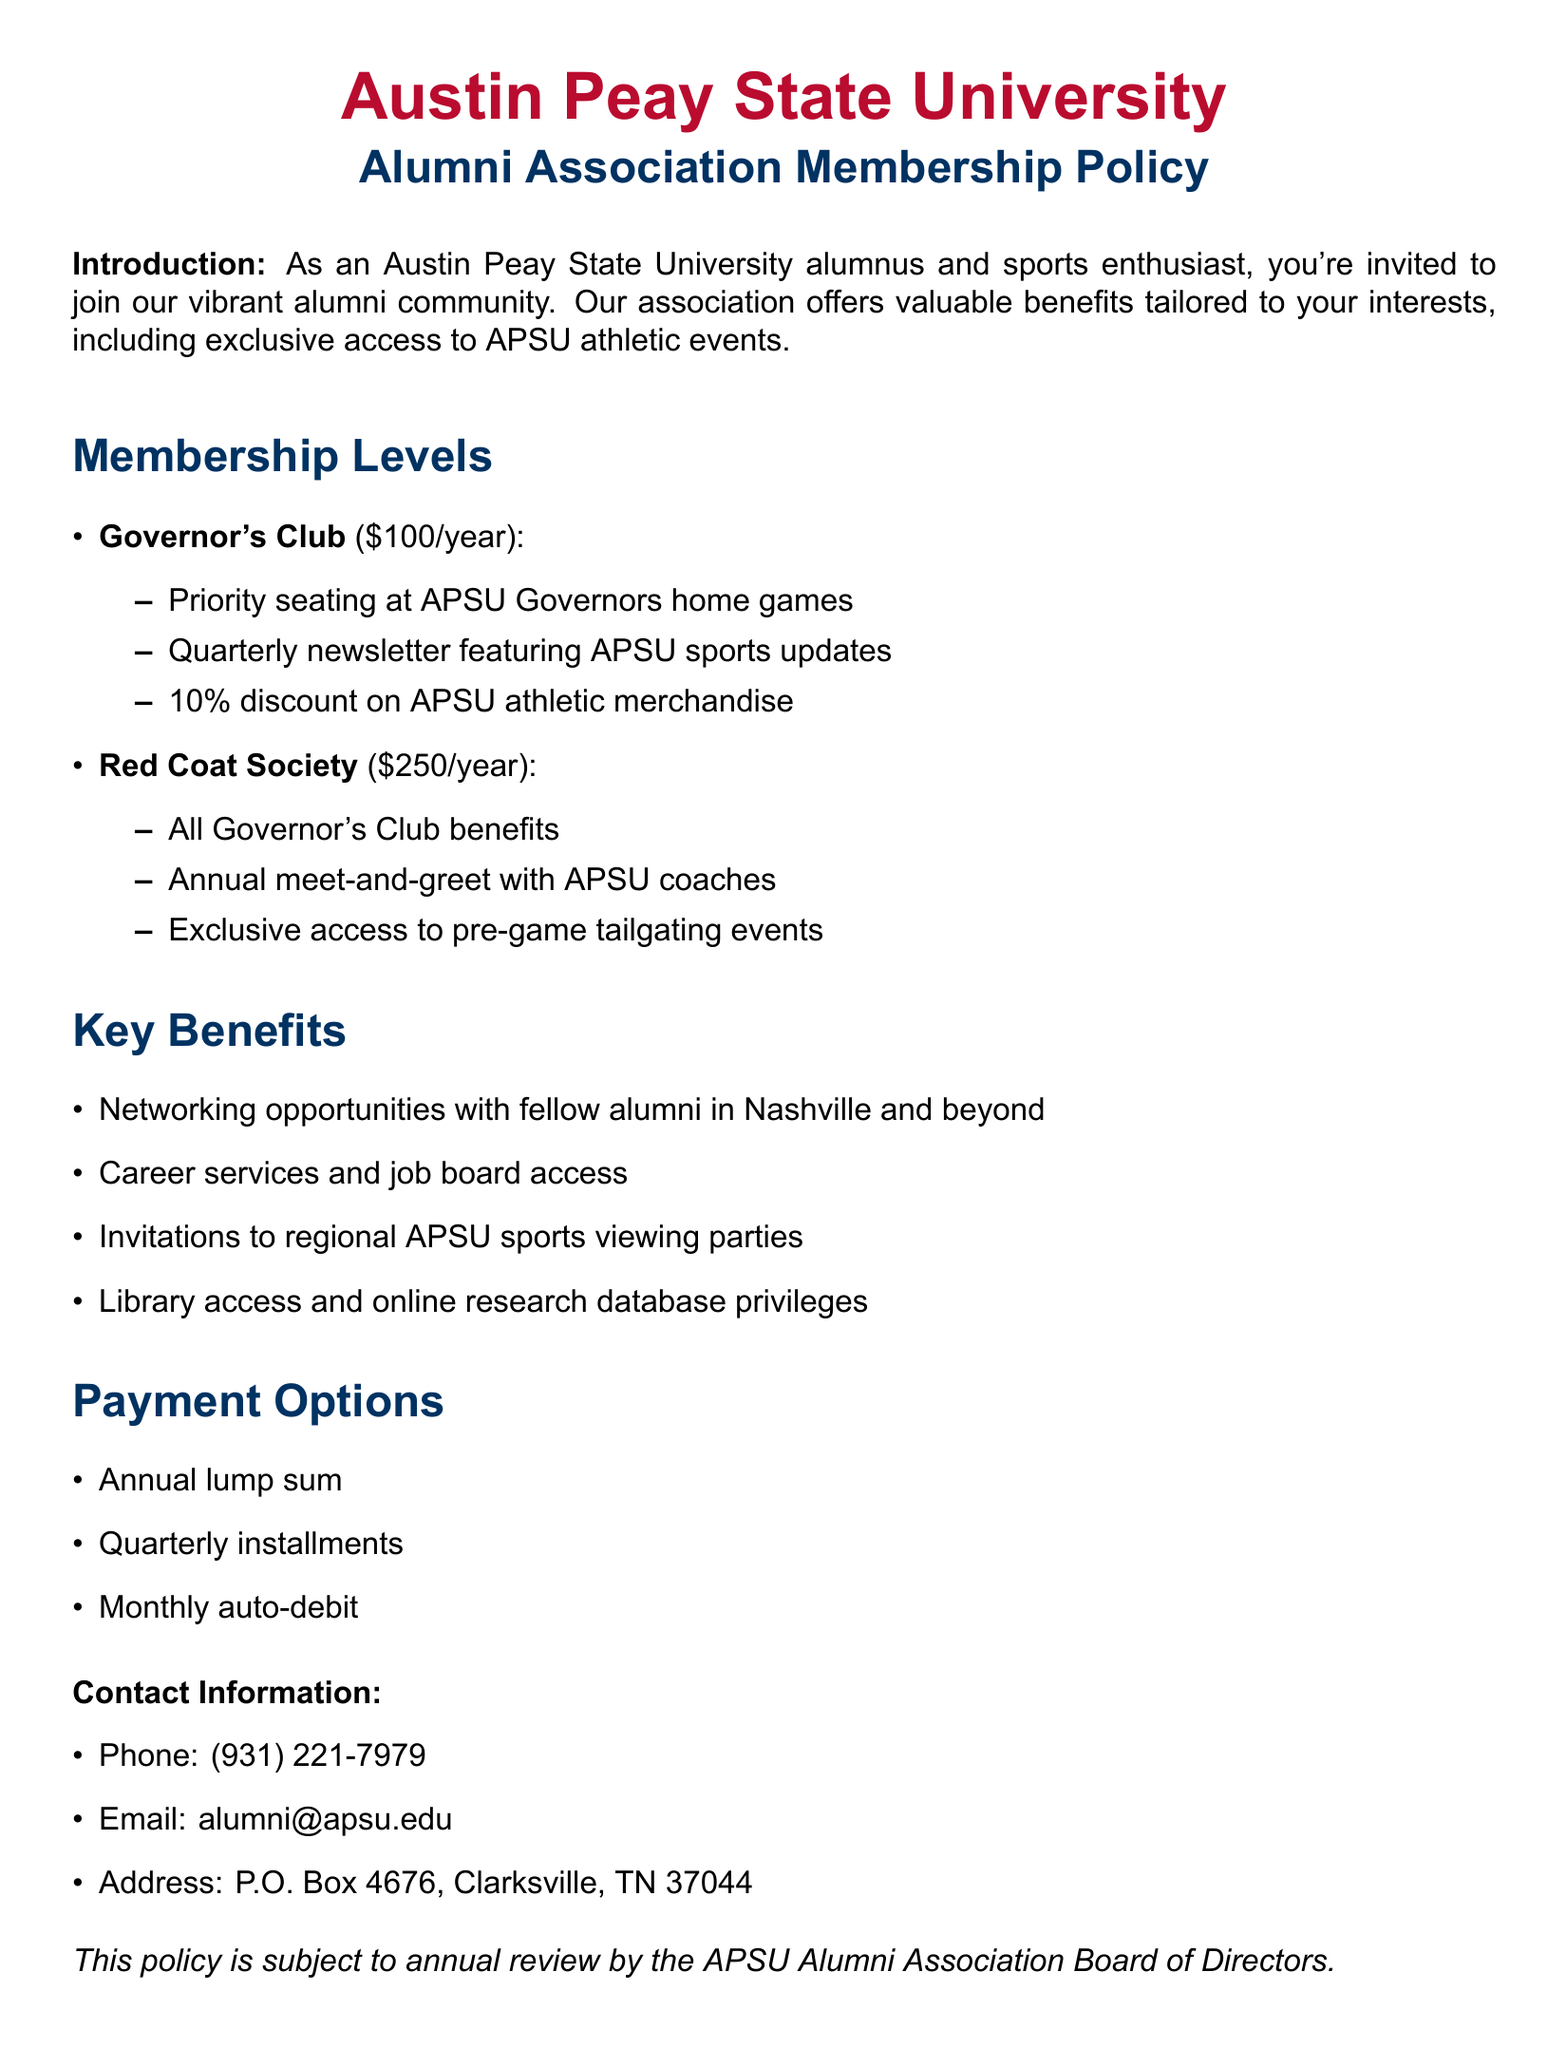What is the membership fee for the Governor's Club? The membership fee for the Governor's Club is stated in the document as $100 per year.
Answer: $100/year What benefits do members of the Red Coat Society receive? The Red Coat Society benefits include all Governor's Club benefits plus additional perks outlined in the document.
Answer: Annual meet-and-greet with APSU coaches, Exclusive access to pre-game tailgating events What discount do Governor's Club members receive on APSU athletic merchandise? The document specifies that Governor's Club members receive a 10% discount on APSU athletic merchandise.
Answer: 10% What is one of the key benefits of alumni membership? The document lists several key benefits; one of them is networking opportunities with fellow alumni in Nashville and beyond.
Answer: Networking opportunities What payment option allows for monthly payments? The document mentions that monthly auto-debit is one of the payment options available for membership dues.
Answer: Monthly auto-debit Which organization reviews the membership policy annually? The policy states that the annual review is conducted by the APSU Alumni Association Board of Directors.
Answer: APSU Alumni Association Board of Directors What is the contact email for alumni inquiries? The document provides an email for alumni inquiries: alumni@apsu.edu.
Answer: alumni@apsu.edu What type of events are alumni invited to for watching sports? The document states that alumni receive invitations to regional APSU sports viewing parties.
Answer: Regional APSU sports viewing parties What is the address listed for contacting the association? The contact address in the document is P.O. Box 4676, Clarksville, TN 37044.
Answer: P.O. Box 4676, Clarksville, TN 37044 